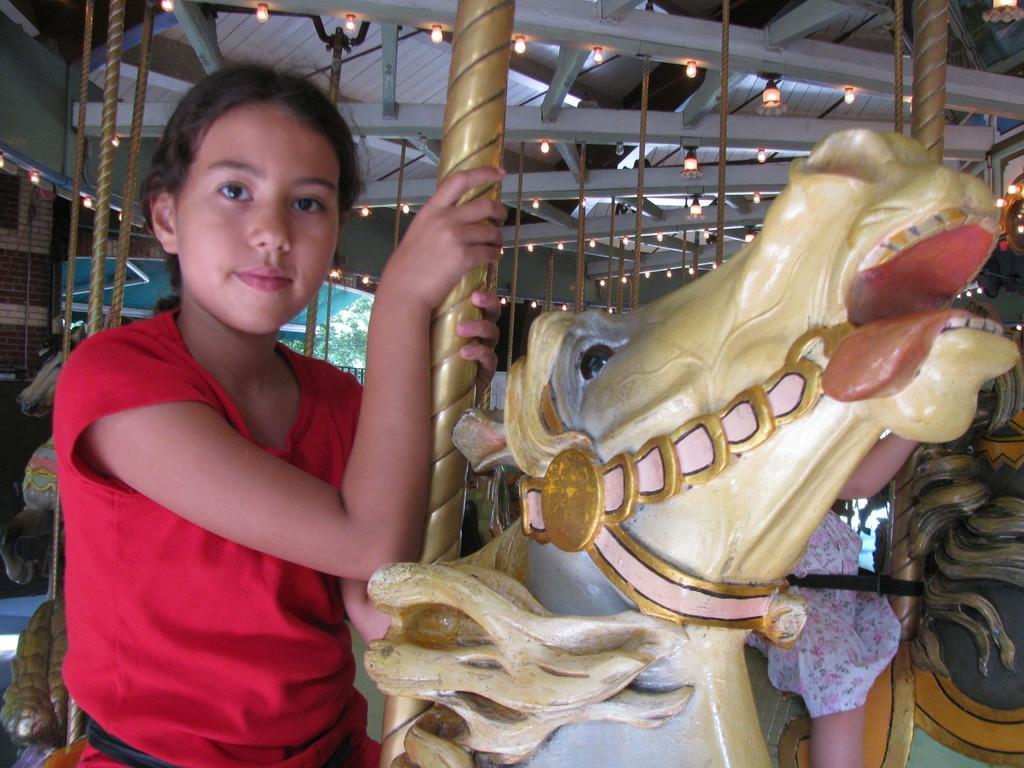How would you summarize this image in a sentence or two? In this image I see girl who is sitting on the toy horse and In the background I see the lights. 